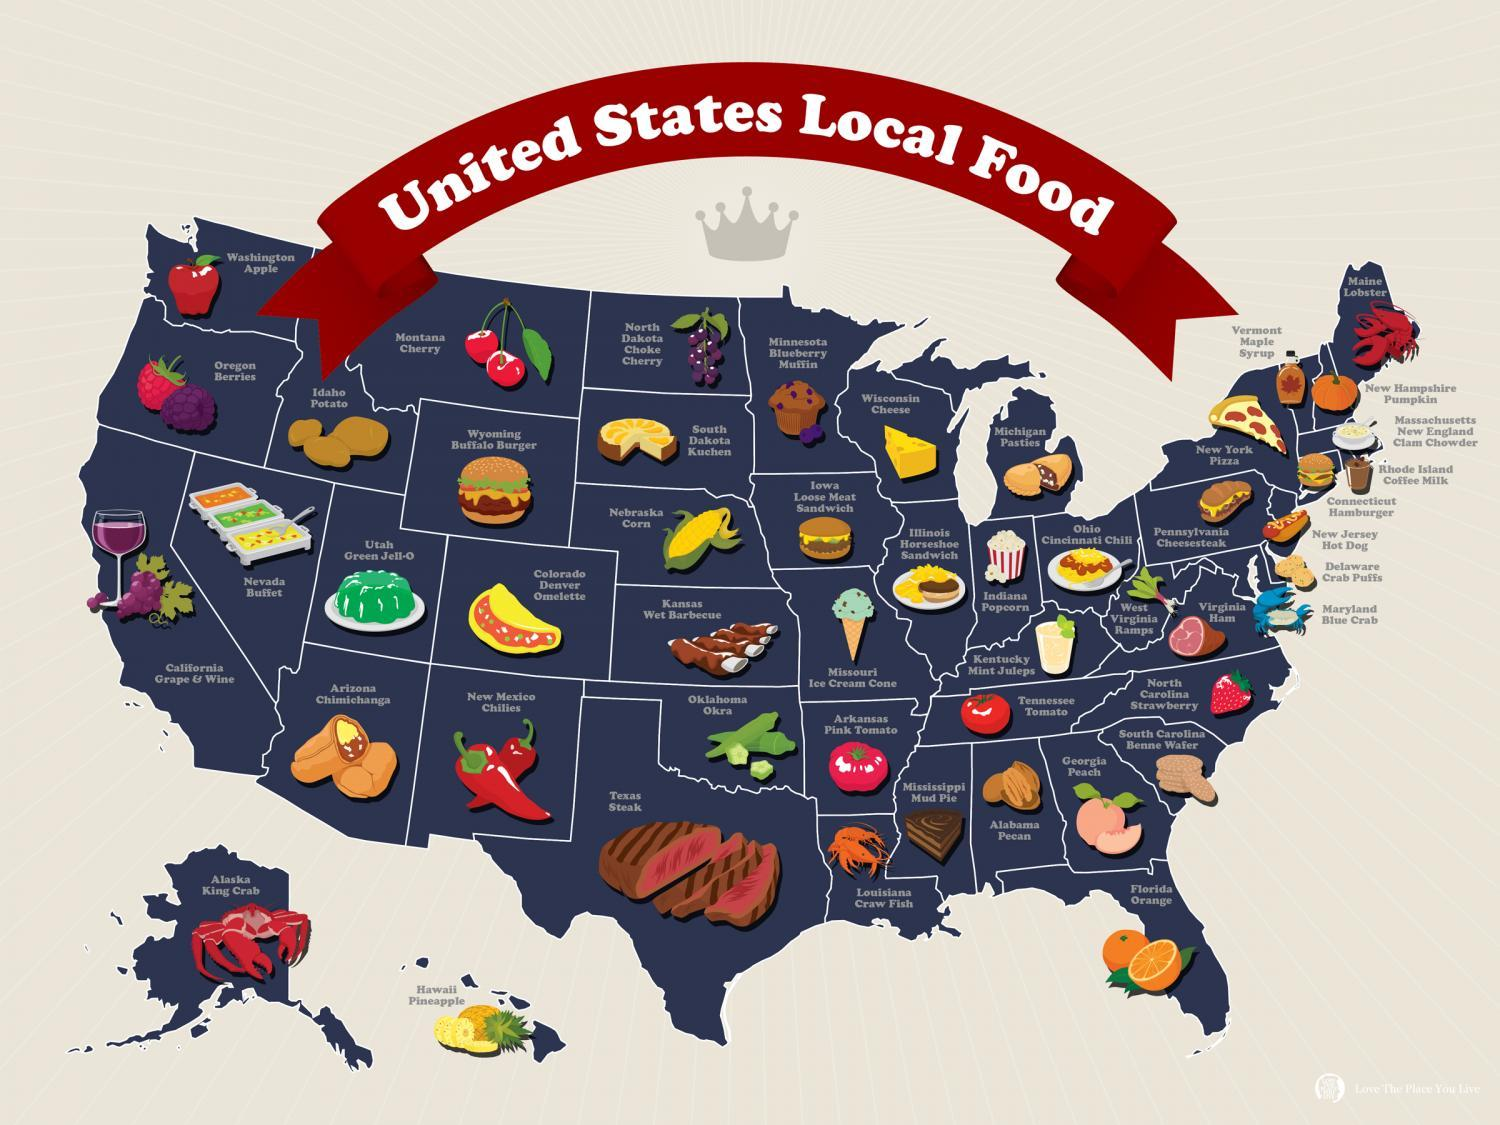What kind of meat is Texas famous for?
Answer the question with a short phrase. Steak What kind of nuts are locally available in Alabama? Alabama Pecan Which is the locally available fruit in Hawaii? Pineapple Which  local food is famous in New york? New York Pizza For which fruit, Georgia is famous for? Georgia Peach What is the locally available seafood in Alaska? Alaska King Crab Which is the most famous spice ingredient used in New Mexico? New Mexico Chillies Which is the famous dessert  in Mississippi state of America? Mississippi Mud Pie 